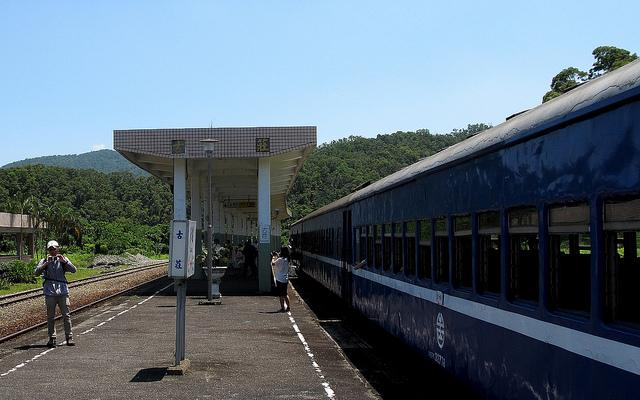Who is sheltered here?

Choices:
A) no one
B) train riders
C) bus riders
D) mall walkers train riders 